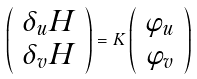Convert formula to latex. <formula><loc_0><loc_0><loc_500><loc_500>\left ( \begin{array} { c } \delta _ { u } H \\ \delta _ { v } H \end{array} \right ) = K \left ( \begin{array} { c } \varphi _ { u } \\ \varphi _ { v } \end{array} \right )</formula> 